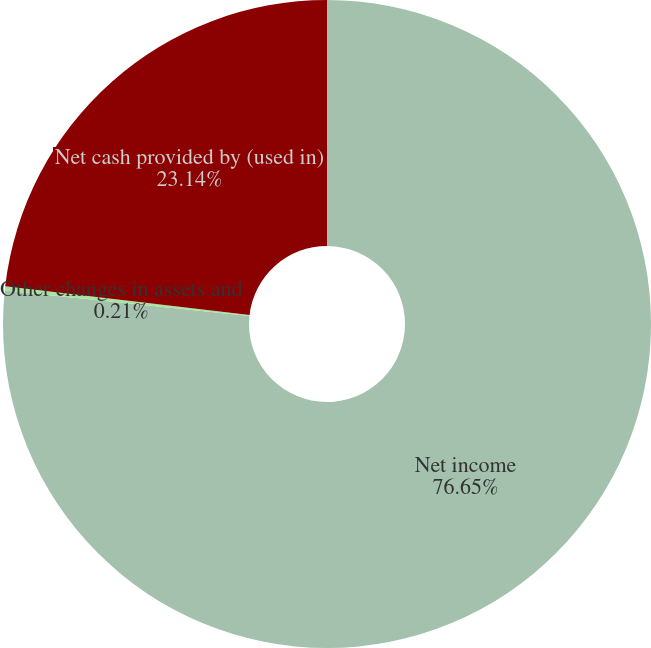Convert chart to OTSL. <chart><loc_0><loc_0><loc_500><loc_500><pie_chart><fcel>Net income<fcel>Other changes in assets and<fcel>Net cash provided by (used in)<nl><fcel>76.65%<fcel>0.21%<fcel>23.14%<nl></chart> 